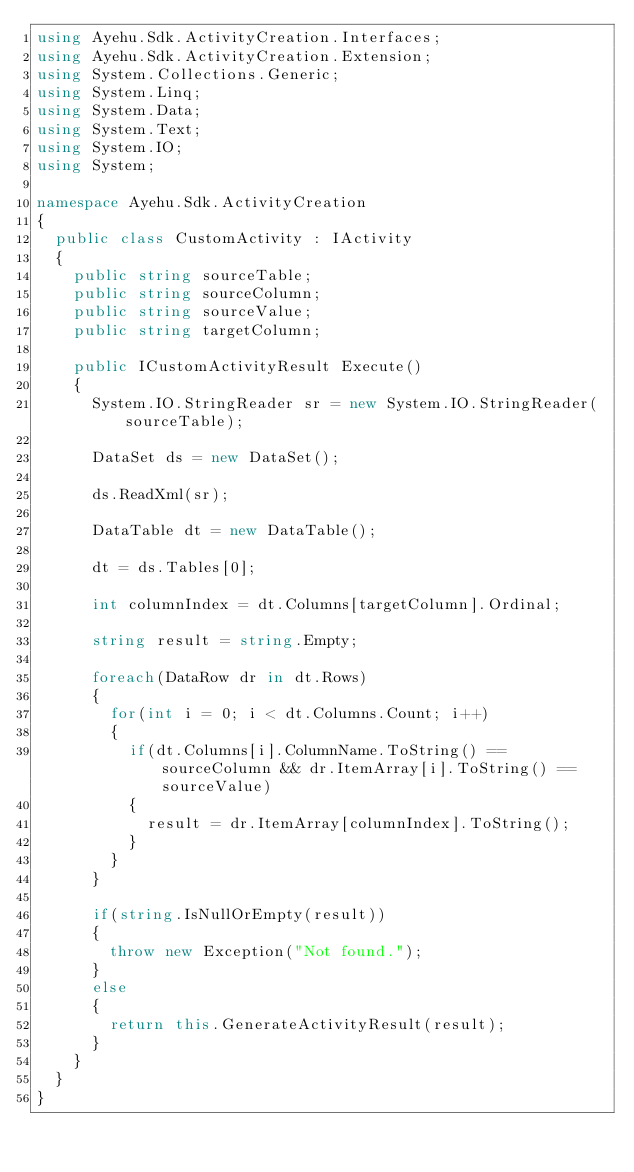Convert code to text. <code><loc_0><loc_0><loc_500><loc_500><_C#_>using Ayehu.Sdk.ActivityCreation.Interfaces;
using Ayehu.Sdk.ActivityCreation.Extension;
using System.Collections.Generic;
using System.Linq;
using System.Data;
using System.Text;
using System.IO;
using System;

namespace Ayehu.Sdk.ActivityCreation
{
	public class CustomActivity : IActivity
	{
		public string sourceTable;
		public string sourceColumn;
		public string sourceValue;
		public string targetColumn;

		public ICustomActivityResult Execute()
		{
			System.IO.StringReader sr = new System.IO.StringReader(sourceTable);

			DataSet ds = new DataSet();

			ds.ReadXml(sr);

			DataTable dt = new DataTable();

			dt = ds.Tables[0];
			
			int columnIndex = dt.Columns[targetColumn].Ordinal;

			string result = string.Empty;
			
			foreach(DataRow dr in dt.Rows)
			{
				for(int i = 0; i < dt.Columns.Count; i++)
				{
					if(dt.Columns[i].ColumnName.ToString() == sourceColumn && dr.ItemArray[i].ToString() == sourceValue)
					{
						result = dr.ItemArray[columnIndex].ToString();
					}
				}
			}

			if(string.IsNullOrEmpty(result))
			{
				throw new Exception("Not found.");
			}
			else
			{
				return this.GenerateActivityResult(result);
			}
		}
	}
}
</code> 